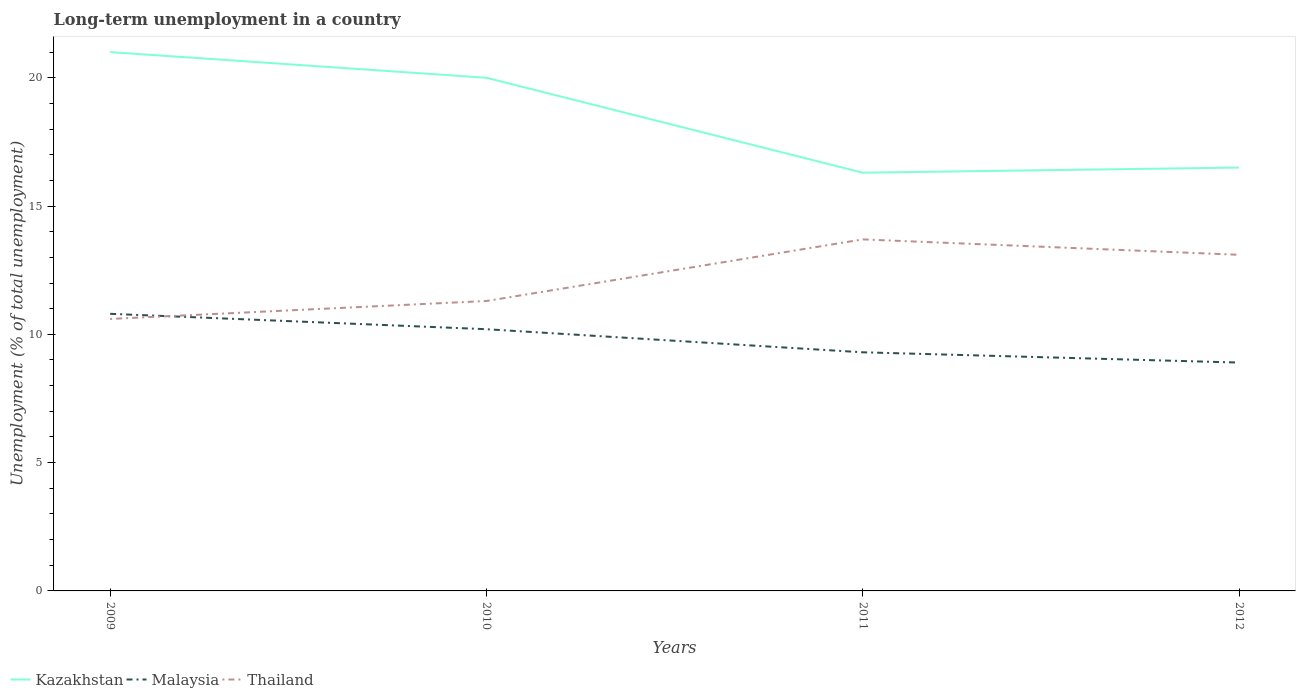Across all years, what is the maximum percentage of long-term unemployed population in Kazakhstan?
Give a very brief answer. 16.3. In which year was the percentage of long-term unemployed population in Thailand maximum?
Provide a succinct answer. 2009. What is the total percentage of long-term unemployed population in Kazakhstan in the graph?
Give a very brief answer. 3.7. What is the difference between the highest and the second highest percentage of long-term unemployed population in Thailand?
Ensure brevity in your answer.  3.1. How many lines are there?
Your answer should be very brief. 3. Does the graph contain any zero values?
Provide a succinct answer. No. How many legend labels are there?
Offer a very short reply. 3. What is the title of the graph?
Provide a short and direct response. Long-term unemployment in a country. What is the label or title of the X-axis?
Your response must be concise. Years. What is the label or title of the Y-axis?
Make the answer very short. Unemployment (% of total unemployment). What is the Unemployment (% of total unemployment) in Kazakhstan in 2009?
Provide a short and direct response. 21. What is the Unemployment (% of total unemployment) of Malaysia in 2009?
Provide a short and direct response. 10.8. What is the Unemployment (% of total unemployment) in Thailand in 2009?
Ensure brevity in your answer.  10.6. What is the Unemployment (% of total unemployment) of Kazakhstan in 2010?
Your response must be concise. 20. What is the Unemployment (% of total unemployment) in Malaysia in 2010?
Ensure brevity in your answer.  10.2. What is the Unemployment (% of total unemployment) of Thailand in 2010?
Give a very brief answer. 11.3. What is the Unemployment (% of total unemployment) of Kazakhstan in 2011?
Your answer should be compact. 16.3. What is the Unemployment (% of total unemployment) in Malaysia in 2011?
Your response must be concise. 9.3. What is the Unemployment (% of total unemployment) of Thailand in 2011?
Your answer should be very brief. 13.7. What is the Unemployment (% of total unemployment) in Malaysia in 2012?
Your answer should be very brief. 8.9. What is the Unemployment (% of total unemployment) in Thailand in 2012?
Your answer should be compact. 13.1. Across all years, what is the maximum Unemployment (% of total unemployment) of Malaysia?
Your answer should be compact. 10.8. Across all years, what is the maximum Unemployment (% of total unemployment) of Thailand?
Offer a very short reply. 13.7. Across all years, what is the minimum Unemployment (% of total unemployment) of Kazakhstan?
Your answer should be compact. 16.3. Across all years, what is the minimum Unemployment (% of total unemployment) in Malaysia?
Ensure brevity in your answer.  8.9. Across all years, what is the minimum Unemployment (% of total unemployment) of Thailand?
Offer a terse response. 10.6. What is the total Unemployment (% of total unemployment) of Kazakhstan in the graph?
Your answer should be compact. 73.8. What is the total Unemployment (% of total unemployment) of Malaysia in the graph?
Your answer should be compact. 39.2. What is the total Unemployment (% of total unemployment) of Thailand in the graph?
Provide a succinct answer. 48.7. What is the difference between the Unemployment (% of total unemployment) of Malaysia in 2009 and that in 2010?
Your answer should be compact. 0.6. What is the difference between the Unemployment (% of total unemployment) in Thailand in 2009 and that in 2010?
Provide a succinct answer. -0.7. What is the difference between the Unemployment (% of total unemployment) of Kazakhstan in 2009 and that in 2011?
Keep it short and to the point. 4.7. What is the difference between the Unemployment (% of total unemployment) in Malaysia in 2009 and that in 2012?
Make the answer very short. 1.9. What is the difference between the Unemployment (% of total unemployment) of Kazakhstan in 2010 and that in 2011?
Provide a short and direct response. 3.7. What is the difference between the Unemployment (% of total unemployment) of Malaysia in 2010 and that in 2012?
Make the answer very short. 1.3. What is the difference between the Unemployment (% of total unemployment) in Thailand in 2010 and that in 2012?
Ensure brevity in your answer.  -1.8. What is the difference between the Unemployment (% of total unemployment) of Malaysia in 2011 and that in 2012?
Provide a short and direct response. 0.4. What is the difference between the Unemployment (% of total unemployment) of Thailand in 2011 and that in 2012?
Your answer should be compact. 0.6. What is the difference between the Unemployment (% of total unemployment) of Kazakhstan in 2009 and the Unemployment (% of total unemployment) of Malaysia in 2012?
Your response must be concise. 12.1. What is the difference between the Unemployment (% of total unemployment) in Kazakhstan in 2009 and the Unemployment (% of total unemployment) in Thailand in 2012?
Your response must be concise. 7.9. What is the difference between the Unemployment (% of total unemployment) of Kazakhstan in 2010 and the Unemployment (% of total unemployment) of Malaysia in 2011?
Offer a very short reply. 10.7. What is the difference between the Unemployment (% of total unemployment) of Kazakhstan in 2010 and the Unemployment (% of total unemployment) of Thailand in 2011?
Keep it short and to the point. 6.3. What is the difference between the Unemployment (% of total unemployment) of Malaysia in 2010 and the Unemployment (% of total unemployment) of Thailand in 2011?
Offer a terse response. -3.5. What is the difference between the Unemployment (% of total unemployment) in Kazakhstan in 2010 and the Unemployment (% of total unemployment) in Malaysia in 2012?
Your answer should be compact. 11.1. What is the difference between the Unemployment (% of total unemployment) of Malaysia in 2010 and the Unemployment (% of total unemployment) of Thailand in 2012?
Keep it short and to the point. -2.9. What is the difference between the Unemployment (% of total unemployment) of Kazakhstan in 2011 and the Unemployment (% of total unemployment) of Thailand in 2012?
Provide a short and direct response. 3.2. What is the average Unemployment (% of total unemployment) in Kazakhstan per year?
Your response must be concise. 18.45. What is the average Unemployment (% of total unemployment) in Malaysia per year?
Provide a succinct answer. 9.8. What is the average Unemployment (% of total unemployment) of Thailand per year?
Make the answer very short. 12.18. In the year 2009, what is the difference between the Unemployment (% of total unemployment) of Malaysia and Unemployment (% of total unemployment) of Thailand?
Your answer should be very brief. 0.2. In the year 2010, what is the difference between the Unemployment (% of total unemployment) of Kazakhstan and Unemployment (% of total unemployment) of Thailand?
Offer a terse response. 8.7. In the year 2010, what is the difference between the Unemployment (% of total unemployment) of Malaysia and Unemployment (% of total unemployment) of Thailand?
Your response must be concise. -1.1. In the year 2011, what is the difference between the Unemployment (% of total unemployment) in Kazakhstan and Unemployment (% of total unemployment) in Thailand?
Keep it short and to the point. 2.6. In the year 2011, what is the difference between the Unemployment (% of total unemployment) in Malaysia and Unemployment (% of total unemployment) in Thailand?
Provide a succinct answer. -4.4. In the year 2012, what is the difference between the Unemployment (% of total unemployment) in Kazakhstan and Unemployment (% of total unemployment) in Thailand?
Keep it short and to the point. 3.4. What is the ratio of the Unemployment (% of total unemployment) of Malaysia in 2009 to that in 2010?
Your answer should be very brief. 1.06. What is the ratio of the Unemployment (% of total unemployment) of Thailand in 2009 to that in 2010?
Keep it short and to the point. 0.94. What is the ratio of the Unemployment (% of total unemployment) of Kazakhstan in 2009 to that in 2011?
Give a very brief answer. 1.29. What is the ratio of the Unemployment (% of total unemployment) of Malaysia in 2009 to that in 2011?
Your answer should be compact. 1.16. What is the ratio of the Unemployment (% of total unemployment) of Thailand in 2009 to that in 2011?
Offer a very short reply. 0.77. What is the ratio of the Unemployment (% of total unemployment) of Kazakhstan in 2009 to that in 2012?
Keep it short and to the point. 1.27. What is the ratio of the Unemployment (% of total unemployment) of Malaysia in 2009 to that in 2012?
Provide a succinct answer. 1.21. What is the ratio of the Unemployment (% of total unemployment) in Thailand in 2009 to that in 2012?
Your response must be concise. 0.81. What is the ratio of the Unemployment (% of total unemployment) in Kazakhstan in 2010 to that in 2011?
Give a very brief answer. 1.23. What is the ratio of the Unemployment (% of total unemployment) in Malaysia in 2010 to that in 2011?
Your response must be concise. 1.1. What is the ratio of the Unemployment (% of total unemployment) in Thailand in 2010 to that in 2011?
Your answer should be very brief. 0.82. What is the ratio of the Unemployment (% of total unemployment) of Kazakhstan in 2010 to that in 2012?
Your answer should be very brief. 1.21. What is the ratio of the Unemployment (% of total unemployment) of Malaysia in 2010 to that in 2012?
Offer a terse response. 1.15. What is the ratio of the Unemployment (% of total unemployment) of Thailand in 2010 to that in 2012?
Make the answer very short. 0.86. What is the ratio of the Unemployment (% of total unemployment) of Kazakhstan in 2011 to that in 2012?
Ensure brevity in your answer.  0.99. What is the ratio of the Unemployment (% of total unemployment) of Malaysia in 2011 to that in 2012?
Offer a terse response. 1.04. What is the ratio of the Unemployment (% of total unemployment) in Thailand in 2011 to that in 2012?
Provide a succinct answer. 1.05. What is the difference between the highest and the second highest Unemployment (% of total unemployment) in Kazakhstan?
Provide a succinct answer. 1. What is the difference between the highest and the lowest Unemployment (% of total unemployment) in Kazakhstan?
Make the answer very short. 4.7. What is the difference between the highest and the lowest Unemployment (% of total unemployment) in Malaysia?
Ensure brevity in your answer.  1.9. What is the difference between the highest and the lowest Unemployment (% of total unemployment) in Thailand?
Offer a terse response. 3.1. 